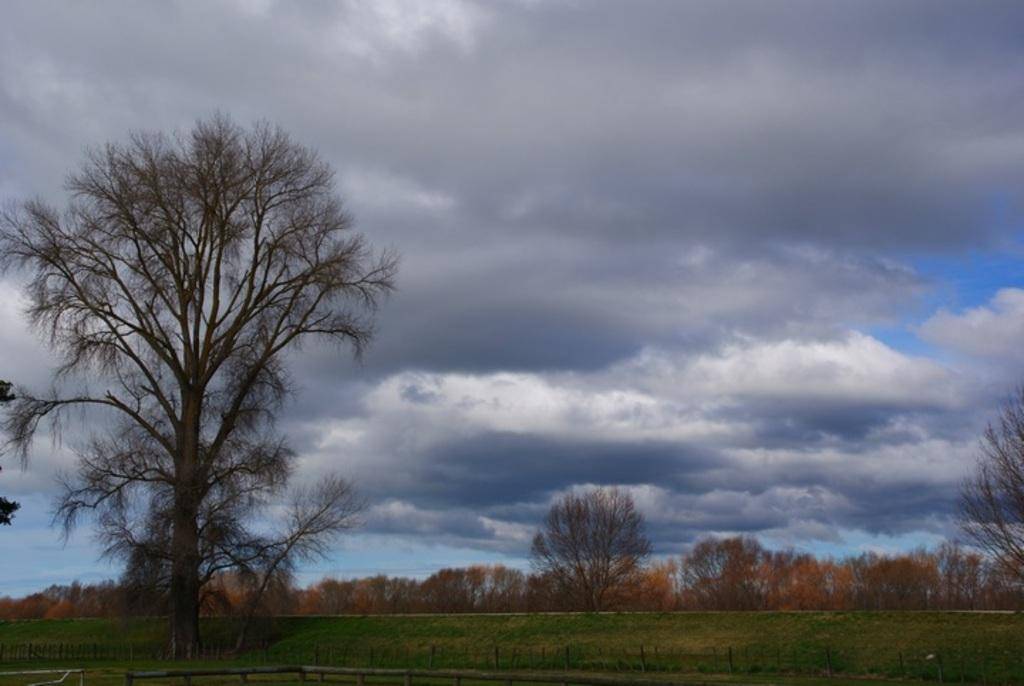What is located on the left side of the image? There is a tree on the left side of the image. What can be seen at the bottom of the image? There is a fence at the bottom of the image. What is present on the ground in the image? There are objects on the ground and grass covering the ground. What is visible in the background of the image? There are trees and clouds in the sky in the background. Can you tell me how many doctors are present in the image? There are no doctors present in the image. What type of fruit is hanging from the tree in the image? There is no fruit visible on the tree in the image. 